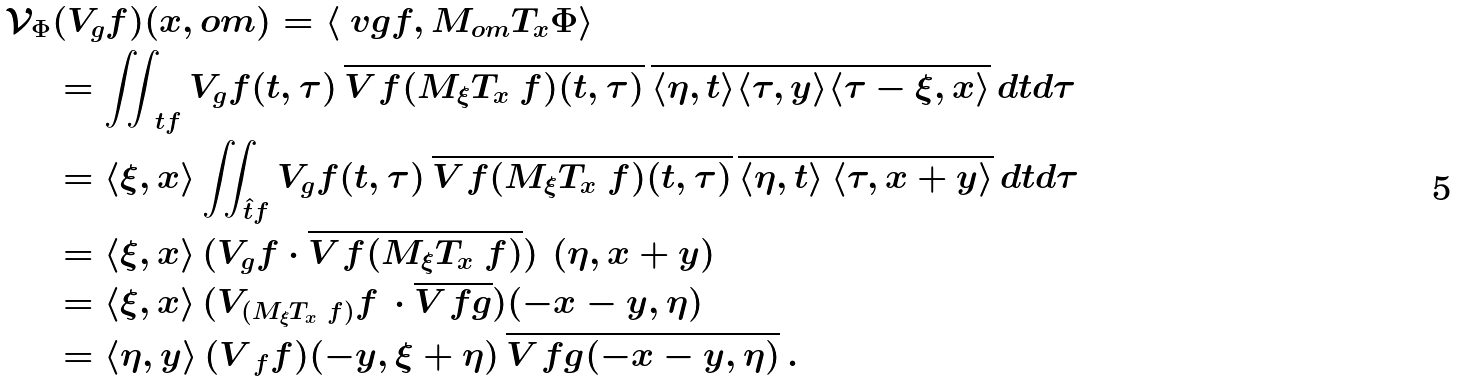Convert formula to latex. <formula><loc_0><loc_0><loc_500><loc_500>\mathcal { V } _ { \Phi } & ( V _ { g } f ) ( x , o m ) = \langle \ v g f , M _ { o m } T _ { x } \Phi \rangle \\ & = \iint _ { \ t f } V _ { g } f ( t , \tau ) \, { \overline { V _ { \ } f ( M _ { \xi } T _ { x } \ f ) ( t , \tau ) } } \, \overline { \langle \eta , t \rangle \langle \tau , y \rangle \langle \tau - \xi , x \rangle } \, d t d \tau \\ & = \langle \xi , x \rangle \iint _ { \hat { t } f } V _ { g } f ( t , \tau ) \, { \overline { V _ { \ } f ( M _ { \xi } T _ { x } \ f ) ( t , \tau ) } } \, \overline { \langle \eta , t \rangle \, \langle \tau , x + y \rangle } \, d t d \tau \\ & = \langle \xi , x \rangle \, ( V _ { g } f \cdot { \overline { V _ { \ } f ( M _ { \xi } T _ { x } \ f ) } } ) \, { } \, ( \eta , x + y ) \\ & = \langle \xi , x \rangle \, ( V _ { ( M _ { \xi } T _ { x } \ f ) } f \, \cdot { \overline { V _ { \ } f g } } ) ( - x - y , \eta ) \\ & = \langle \eta , y \rangle \, ( V _ { \ f } f ) ( - y , \xi + \eta ) \, \overline { V _ { \ } f g ( - x - y , \eta ) } \, .</formula> 